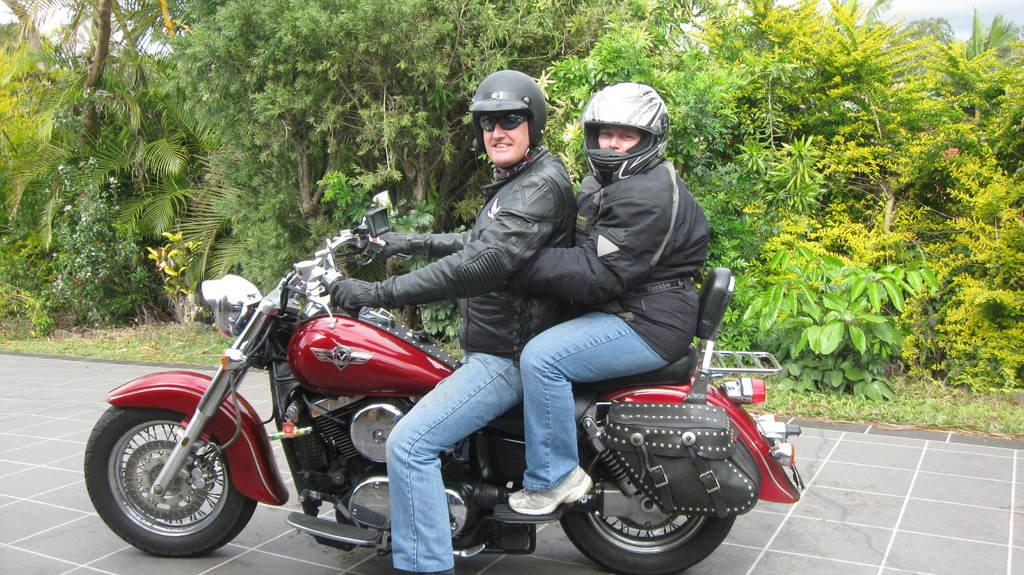How many people are in the group shown in the image? There is a group of persons in the image. What type of clothing are the persons wearing? The persons are wearing jackets, helmets, and goggles. What are the persons sitting on in the image? The group is sitting on a motorcycle. Where is the motorcycle located in the image? The motorcycle is parked on the ground. What can be seen in the background of the image? There are trees and the sky visible in the background of the image. What type of wound can be seen on the turkey in the image? There is no turkey present in the image, and therefore no wound can be observed. 